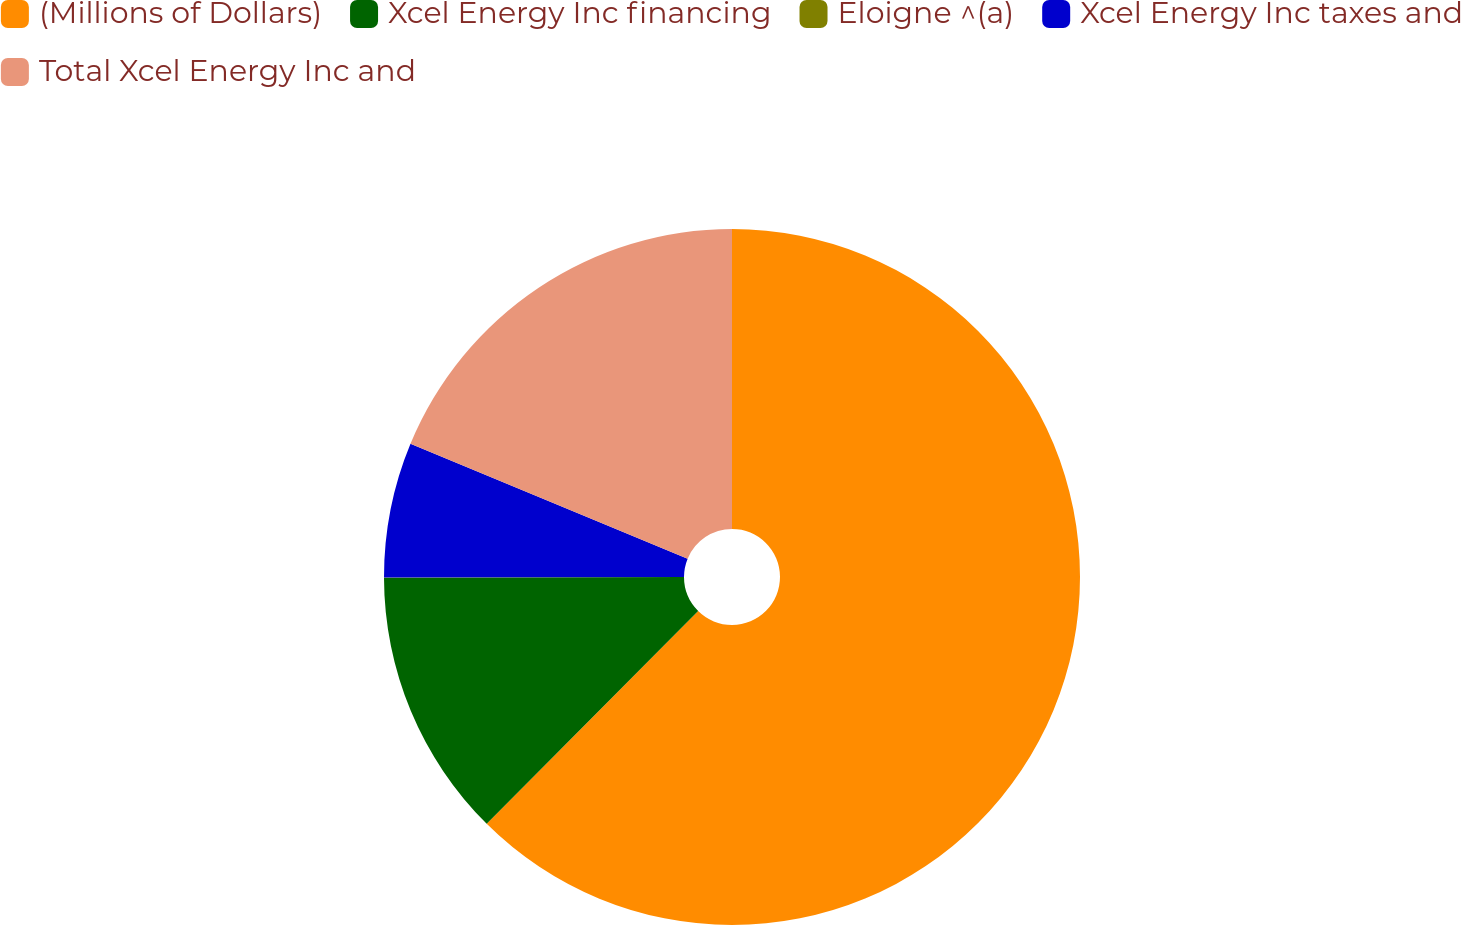Convert chart to OTSL. <chart><loc_0><loc_0><loc_500><loc_500><pie_chart><fcel>(Millions of Dollars)<fcel>Xcel Energy Inc financing<fcel>Eloigne ^(a)<fcel>Xcel Energy Inc taxes and<fcel>Total Xcel Energy Inc and<nl><fcel>62.45%<fcel>12.51%<fcel>0.02%<fcel>6.27%<fcel>18.75%<nl></chart> 